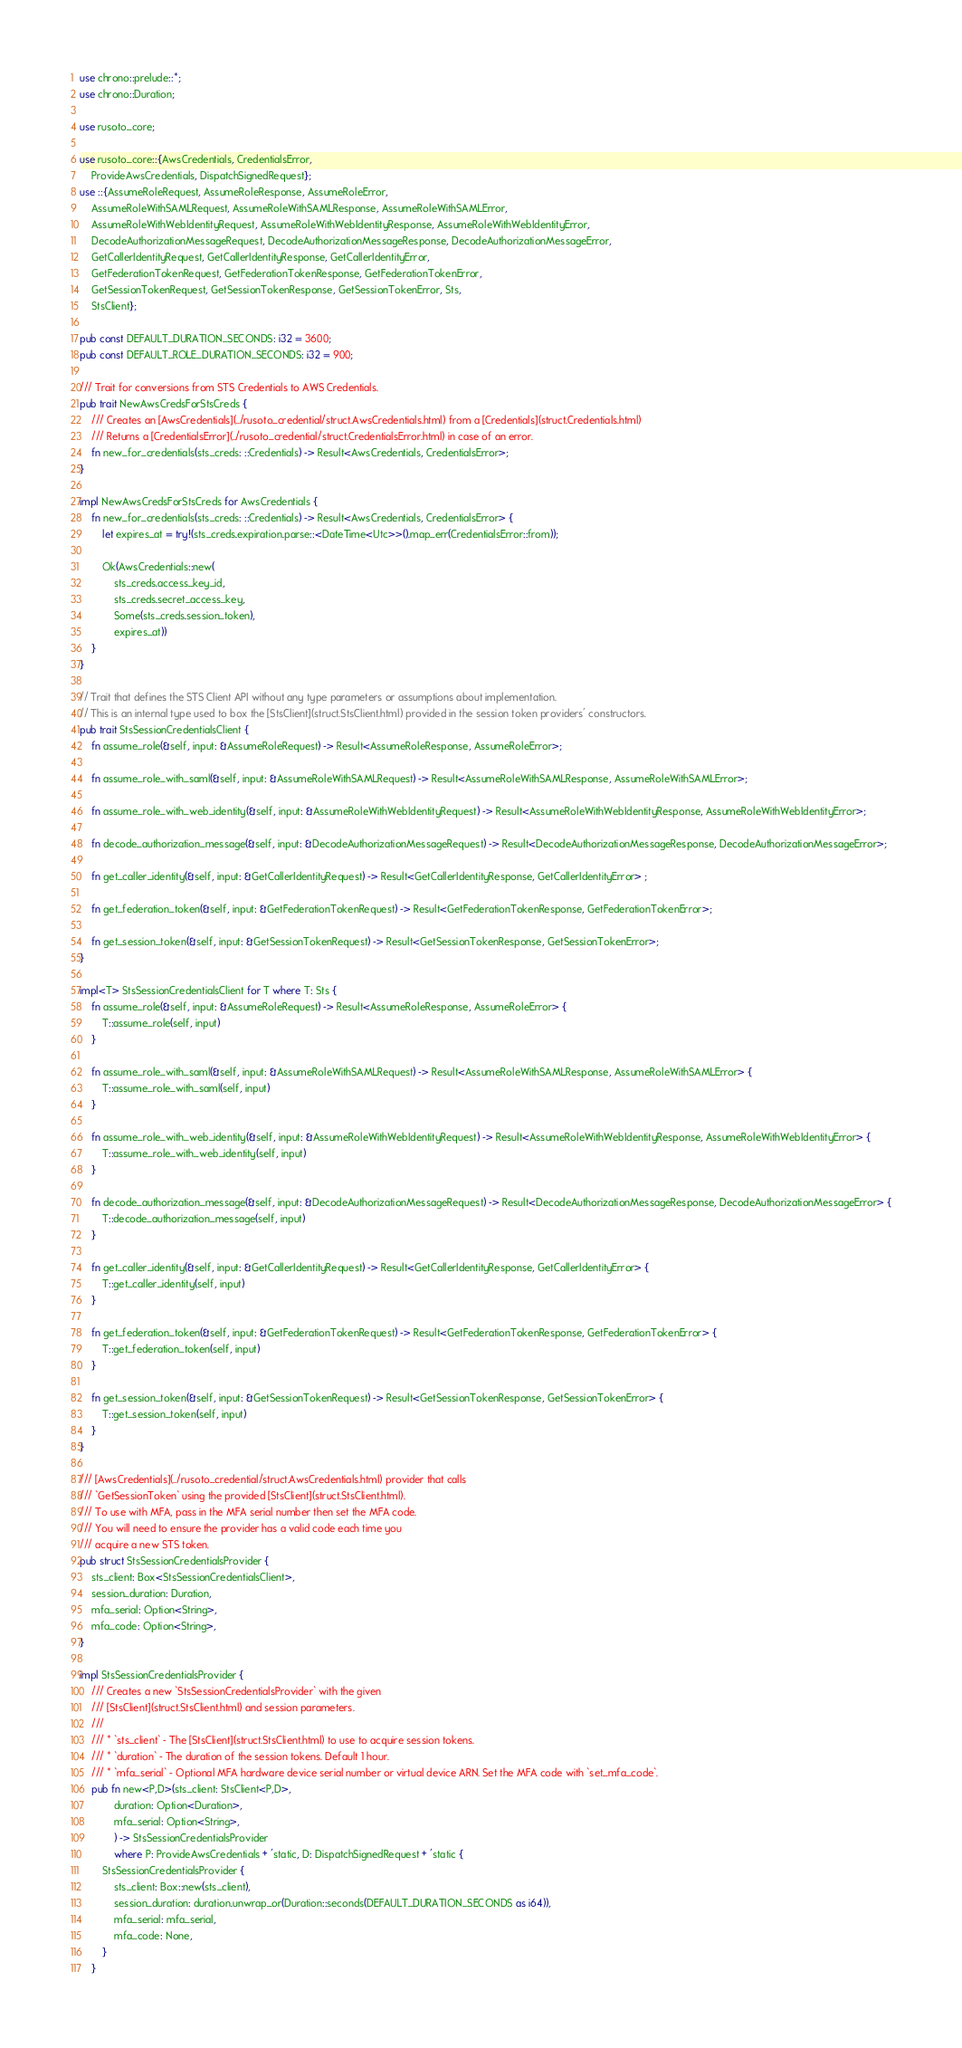<code> <loc_0><loc_0><loc_500><loc_500><_Rust_>use chrono::prelude::*;
use chrono::Duration;

use rusoto_core;

use rusoto_core::{AwsCredentials, CredentialsError,
    ProvideAwsCredentials, DispatchSignedRequest};
use ::{AssumeRoleRequest, AssumeRoleResponse, AssumeRoleError,
    AssumeRoleWithSAMLRequest, AssumeRoleWithSAMLResponse, AssumeRoleWithSAMLError,
    AssumeRoleWithWebIdentityRequest, AssumeRoleWithWebIdentityResponse, AssumeRoleWithWebIdentityError,
    DecodeAuthorizationMessageRequest, DecodeAuthorizationMessageResponse, DecodeAuthorizationMessageError,
    GetCallerIdentityRequest, GetCallerIdentityResponse, GetCallerIdentityError,
    GetFederationTokenRequest, GetFederationTokenResponse, GetFederationTokenError,
    GetSessionTokenRequest, GetSessionTokenResponse, GetSessionTokenError, Sts,
    StsClient};

pub const DEFAULT_DURATION_SECONDS: i32 = 3600;
pub const DEFAULT_ROLE_DURATION_SECONDS: i32 = 900;

/// Trait for conversions from STS Credentials to AWS Credentials.
pub trait NewAwsCredsForStsCreds {
    /// Creates an [AwsCredentials](../rusoto_credential/struct.AwsCredentials.html) from a [Credentials](struct.Credentials.html)
    /// Returns a [CredentialsError](../rusoto_credential/struct.CredentialsError.html) in case of an error.
    fn new_for_credentials(sts_creds: ::Credentials) -> Result<AwsCredentials, CredentialsError>;
}

impl NewAwsCredsForStsCreds for AwsCredentials {
    fn new_for_credentials(sts_creds: ::Credentials) -> Result<AwsCredentials, CredentialsError> {
        let expires_at = try!(sts_creds.expiration.parse::<DateTime<Utc>>().map_err(CredentialsError::from));

        Ok(AwsCredentials::new(
            sts_creds.access_key_id, 
            sts_creds.secret_access_key, 
            Some(sts_creds.session_token), 
            expires_at))
    }
}

// Trait that defines the STS Client API without any type parameters or assumptions about implementation.
// This is an internal type used to box the [StsClient](struct.StsClient.html) provided in the session token providers' constructors.
pub trait StsSessionCredentialsClient {
    fn assume_role(&self, input: &AssumeRoleRequest) -> Result<AssumeRoleResponse, AssumeRoleError>;

    fn assume_role_with_saml(&self, input: &AssumeRoleWithSAMLRequest) -> Result<AssumeRoleWithSAMLResponse, AssumeRoleWithSAMLError>;

    fn assume_role_with_web_identity(&self, input: &AssumeRoleWithWebIdentityRequest) -> Result<AssumeRoleWithWebIdentityResponse, AssumeRoleWithWebIdentityError>;

    fn decode_authorization_message(&self, input: &DecodeAuthorizationMessageRequest) -> Result<DecodeAuthorizationMessageResponse, DecodeAuthorizationMessageError>;

    fn get_caller_identity(&self, input: &GetCallerIdentityRequest) -> Result<GetCallerIdentityResponse, GetCallerIdentityError> ;

    fn get_federation_token(&self, input: &GetFederationTokenRequest) -> Result<GetFederationTokenResponse, GetFederationTokenError>;

    fn get_session_token(&self, input: &GetSessionTokenRequest) -> Result<GetSessionTokenResponse, GetSessionTokenError>;
}

impl<T> StsSessionCredentialsClient for T where T: Sts {
    fn assume_role(&self, input: &AssumeRoleRequest) -> Result<AssumeRoleResponse, AssumeRoleError> {
        T::assume_role(self, input)
    }

    fn assume_role_with_saml(&self, input: &AssumeRoleWithSAMLRequest) -> Result<AssumeRoleWithSAMLResponse, AssumeRoleWithSAMLError> {
        T::assume_role_with_saml(self, input)
    }

    fn assume_role_with_web_identity(&self, input: &AssumeRoleWithWebIdentityRequest) -> Result<AssumeRoleWithWebIdentityResponse, AssumeRoleWithWebIdentityError> {
        T::assume_role_with_web_identity(self, input)
    }

    fn decode_authorization_message(&self, input: &DecodeAuthorizationMessageRequest) -> Result<DecodeAuthorizationMessageResponse, DecodeAuthorizationMessageError> {
        T::decode_authorization_message(self, input)
    }

    fn get_caller_identity(&self, input: &GetCallerIdentityRequest) -> Result<GetCallerIdentityResponse, GetCallerIdentityError> {
        T::get_caller_identity(self, input)
    }

    fn get_federation_token(&self, input: &GetFederationTokenRequest) -> Result<GetFederationTokenResponse, GetFederationTokenError> {
        T::get_federation_token(self, input)
    }

    fn get_session_token(&self, input: &GetSessionTokenRequest) -> Result<GetSessionTokenResponse, GetSessionTokenError> {
        T::get_session_token(self, input)
    }
}

/// [AwsCredentials](../rusoto_credential/struct.AwsCredentials.html) provider that calls
/// `GetSessionToken` using the provided [StsClient](struct.StsClient.html).
/// To use with MFA, pass in the MFA serial number then set the MFA code.
/// You will need to ensure the provider has a valid code each time you
/// acquire a new STS token.
pub struct StsSessionCredentialsProvider {
    sts_client: Box<StsSessionCredentialsClient>,
    session_duration: Duration,
    mfa_serial: Option<String>,
    mfa_code: Option<String>,
}

impl StsSessionCredentialsProvider {
    /// Creates a new `StsSessionCredentialsProvider` with the given
    /// [StsClient](struct.StsClient.html) and session parameters.
    ///
    /// * `sts_client` - The [StsClient](struct.StsClient.html) to use to acquire session tokens.
    /// * `duration` - The duration of the session tokens. Default 1 hour.
    /// * `mfa_serial` - Optional MFA hardware device serial number or virtual device ARN. Set the MFA code with `set_mfa_code`.
    pub fn new<P,D>(sts_client: StsClient<P,D>,
            duration: Option<Duration>,
            mfa_serial: Option<String>,
            ) -> StsSessionCredentialsProvider 
            where P: ProvideAwsCredentials + 'static, D: DispatchSignedRequest + 'static {
        StsSessionCredentialsProvider {
            sts_client: Box::new(sts_client),
            session_duration: duration.unwrap_or(Duration::seconds(DEFAULT_DURATION_SECONDS as i64)),
            mfa_serial: mfa_serial,
            mfa_code: None,
        }
    }
</code> 